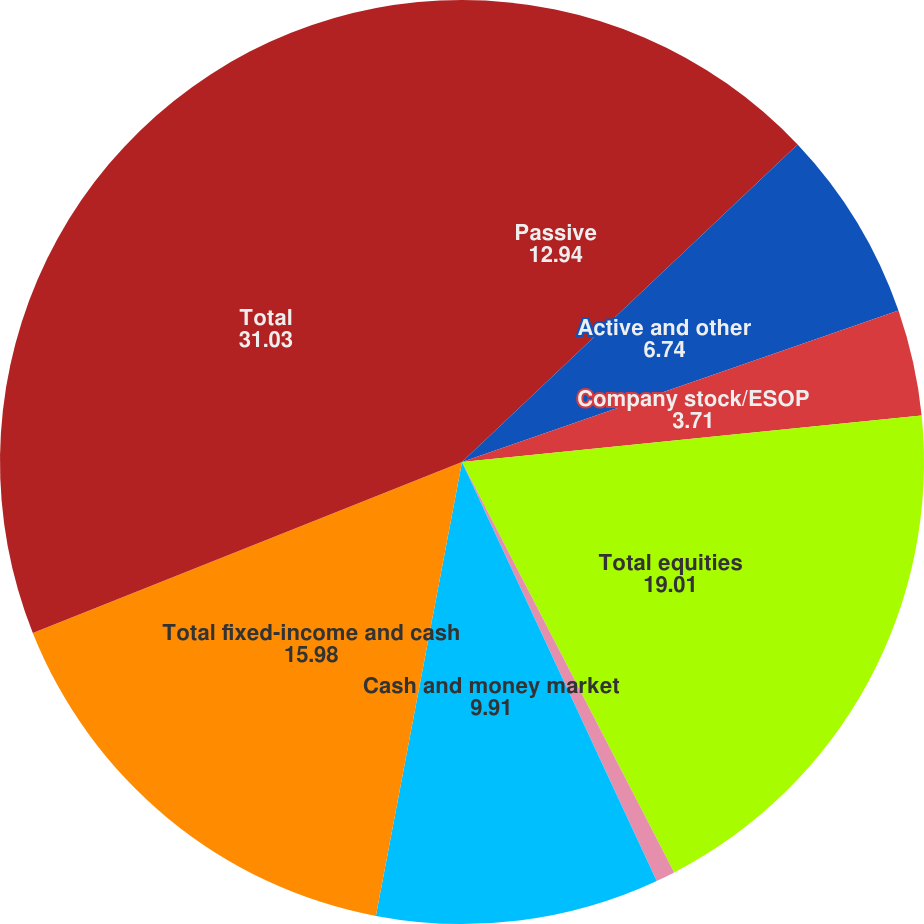<chart> <loc_0><loc_0><loc_500><loc_500><pie_chart><fcel>Passive<fcel>Active and other<fcel>Company stock/ESOP<fcel>Total equities<fcel>Active<fcel>Cash and money market<fcel>Total fixed-income and cash<fcel>Total<nl><fcel>12.94%<fcel>6.74%<fcel>3.71%<fcel>19.01%<fcel>0.67%<fcel>9.91%<fcel>15.98%<fcel>31.03%<nl></chart> 